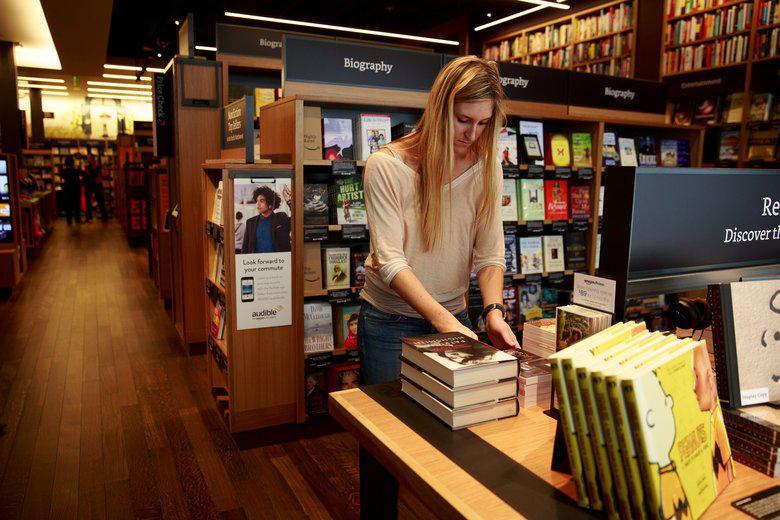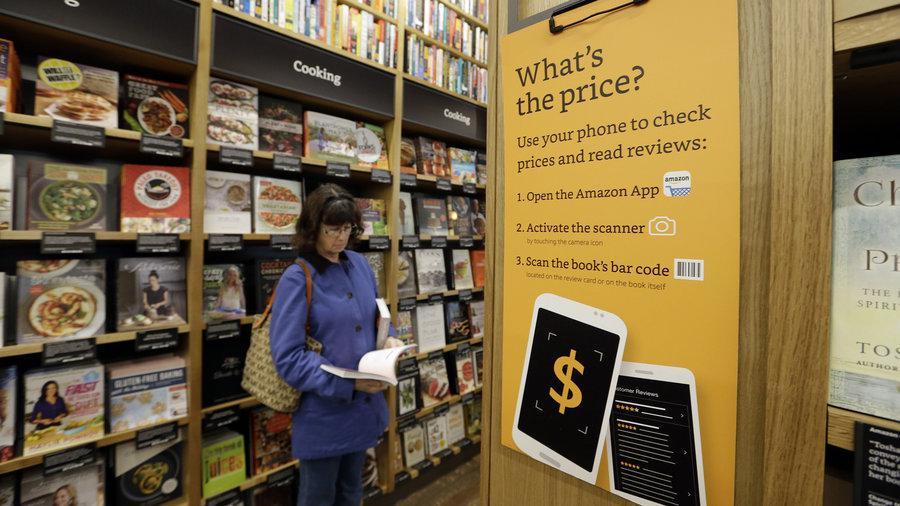The first image is the image on the left, the second image is the image on the right. Assess this claim about the two images: "There are people looking at books in the bookstore in both images.". Correct or not? Answer yes or no. Yes. 